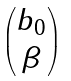<formula> <loc_0><loc_0><loc_500><loc_500>\begin{pmatrix} b _ { 0 } \\ \beta \end{pmatrix}</formula> 